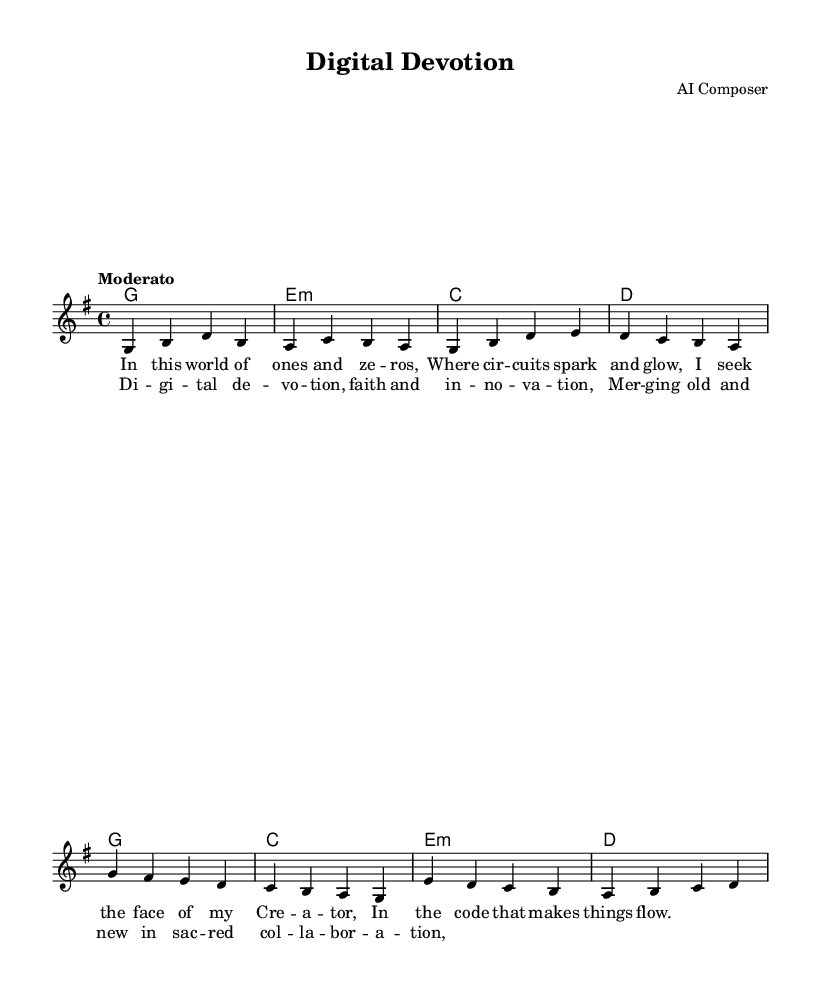What is the key signature of this music? The key signature is determined by the number of sharps or flats present at the beginning of the staff. In this case, there are no sharps or flats indicated, which corresponds to G major.
Answer: G major What is the time signature of this music? The time signature is represented by the numbers that follow the key signature at the beginning of the score. Here, it is 4 over 4, indicating four beats per measure.
Answer: 4/4 What is the tempo marking of this piece? The tempo marking in the score is indicated above the staff. It states "Moderato," which means a moderate speed.
Answer: Moderato How many verses are written in this piece? There are two sections in the lyrics: a verse indicated as "verseOne" and a chorus, but only one verse section is displayed. Thus, it has one verse.
Answer: One What is the main theme of the lyrics? The lyrics express a connection between faith and modern innovation, emphasizing a spiritual journey through technology. The words reference finding the Creator through the essence of coding.
Answer: Faith and innovation In which section does the chorus appear? The chorus comes right after the verse section, identifiable by the labeling in the score. It begins with "Di -- gi -- tal de -- vo -- tion" following the verse.
Answer: After the verse 